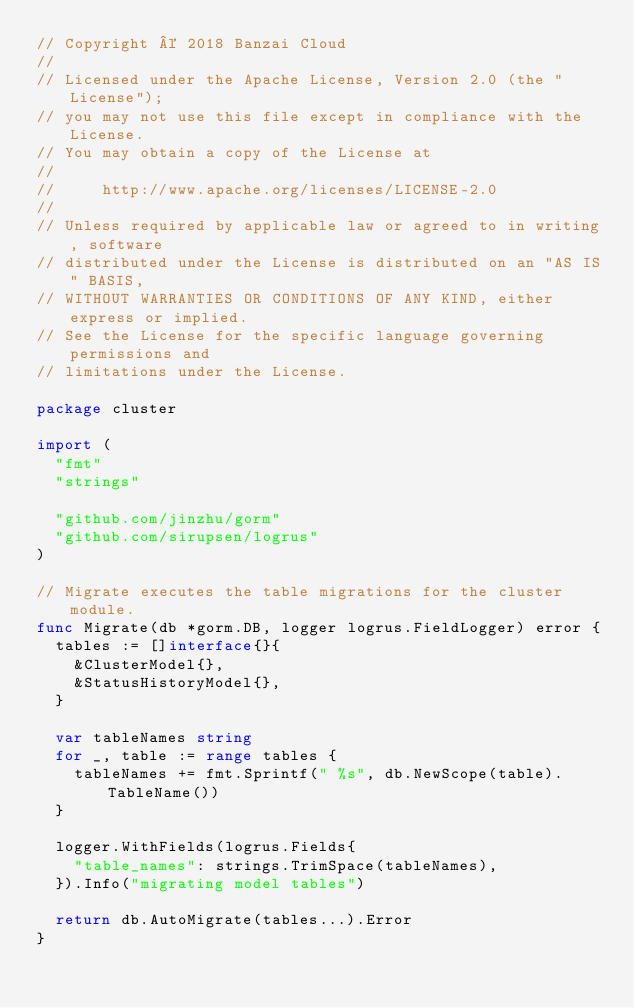<code> <loc_0><loc_0><loc_500><loc_500><_Go_>// Copyright © 2018 Banzai Cloud
//
// Licensed under the Apache License, Version 2.0 (the "License");
// you may not use this file except in compliance with the License.
// You may obtain a copy of the License at
//
//     http://www.apache.org/licenses/LICENSE-2.0
//
// Unless required by applicable law or agreed to in writing, software
// distributed under the License is distributed on an "AS IS" BASIS,
// WITHOUT WARRANTIES OR CONDITIONS OF ANY KIND, either express or implied.
// See the License for the specific language governing permissions and
// limitations under the License.

package cluster

import (
	"fmt"
	"strings"

	"github.com/jinzhu/gorm"
	"github.com/sirupsen/logrus"
)

// Migrate executes the table migrations for the cluster module.
func Migrate(db *gorm.DB, logger logrus.FieldLogger) error {
	tables := []interface{}{
		&ClusterModel{},
		&StatusHistoryModel{},
	}

	var tableNames string
	for _, table := range tables {
		tableNames += fmt.Sprintf(" %s", db.NewScope(table).TableName())
	}

	logger.WithFields(logrus.Fields{
		"table_names": strings.TrimSpace(tableNames),
	}).Info("migrating model tables")

	return db.AutoMigrate(tables...).Error
}
</code> 